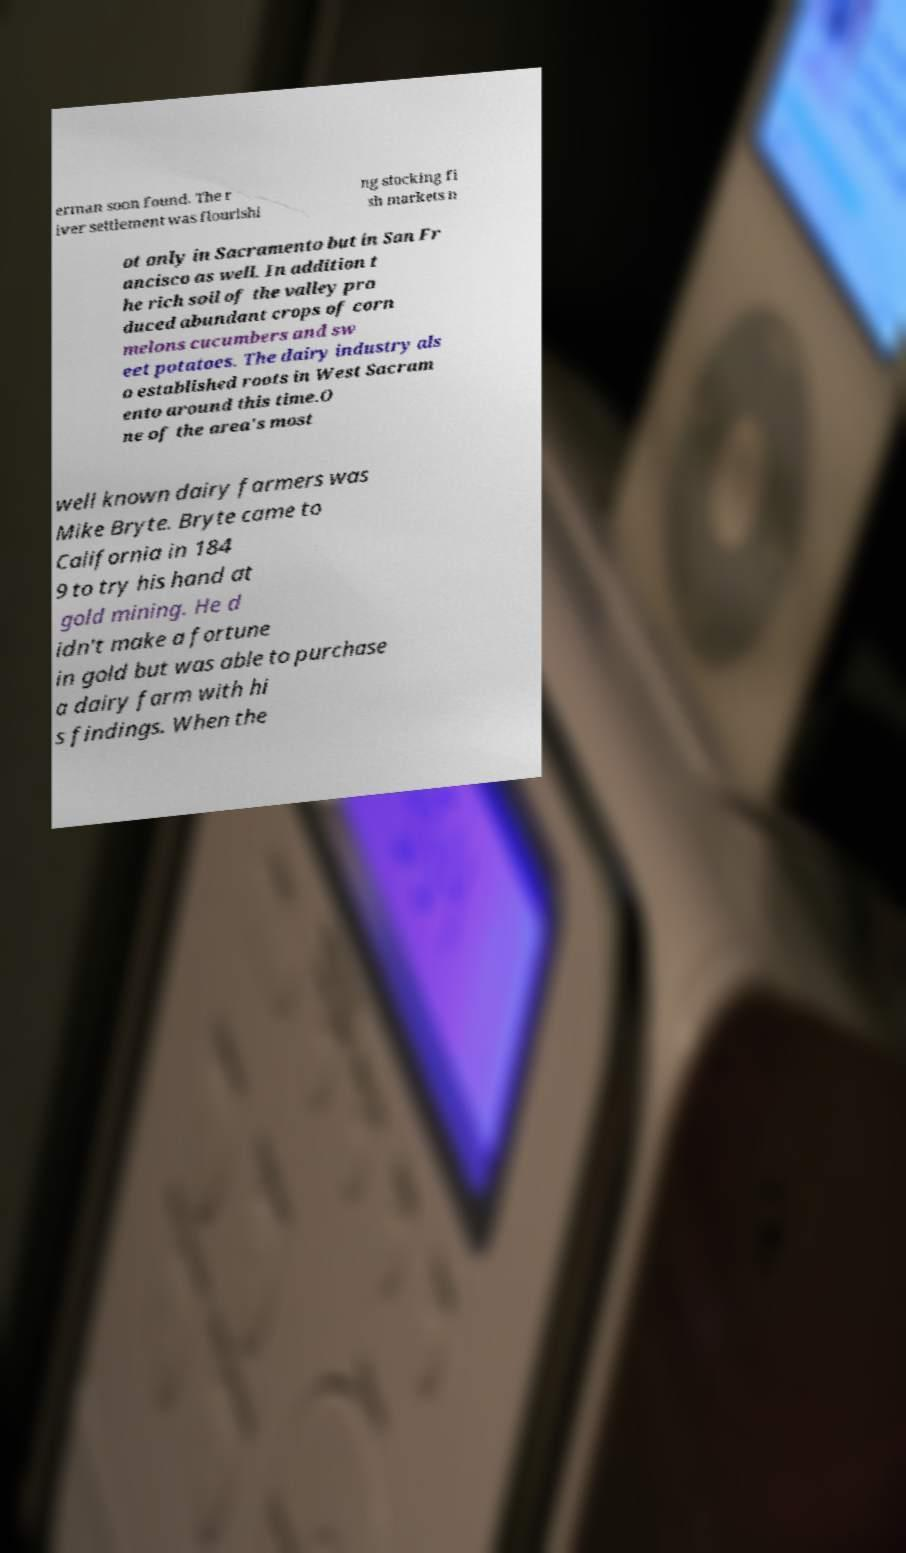Can you accurately transcribe the text from the provided image for me? erman soon found. The r iver settlement was flourishi ng stocking fi sh markets n ot only in Sacramento but in San Fr ancisco as well. In addition t he rich soil of the valley pro duced abundant crops of corn melons cucumbers and sw eet potatoes. The dairy industry als o established roots in West Sacram ento around this time.O ne of the area's most well known dairy farmers was Mike Bryte. Bryte came to California in 184 9 to try his hand at gold mining. He d idn't make a fortune in gold but was able to purchase a dairy farm with hi s findings. When the 